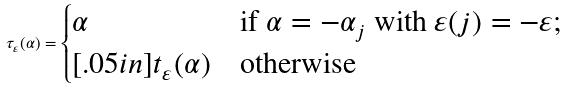Convert formula to latex. <formula><loc_0><loc_0><loc_500><loc_500>\tau _ { \varepsilon } ( \alpha ) = \begin{cases} \alpha & \text {if $\alpha = -\alpha_{j}$ with $\varepsilon(j) = -\varepsilon$;} \\ [ . 0 5 i n ] t _ { \varepsilon } ( \alpha ) & \text {otherwise} \end{cases}</formula> 